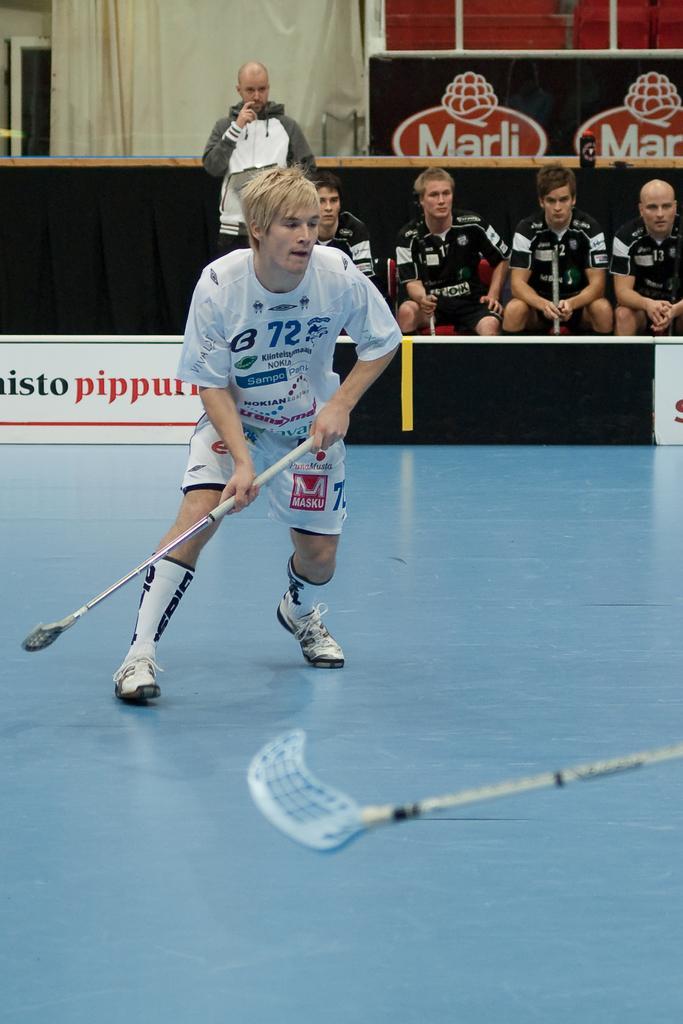Can you describe this image briefly? There is a man holding stick and right side of the image we can see stick. Background there are four people sitting and this man standing and we can see curtain. 